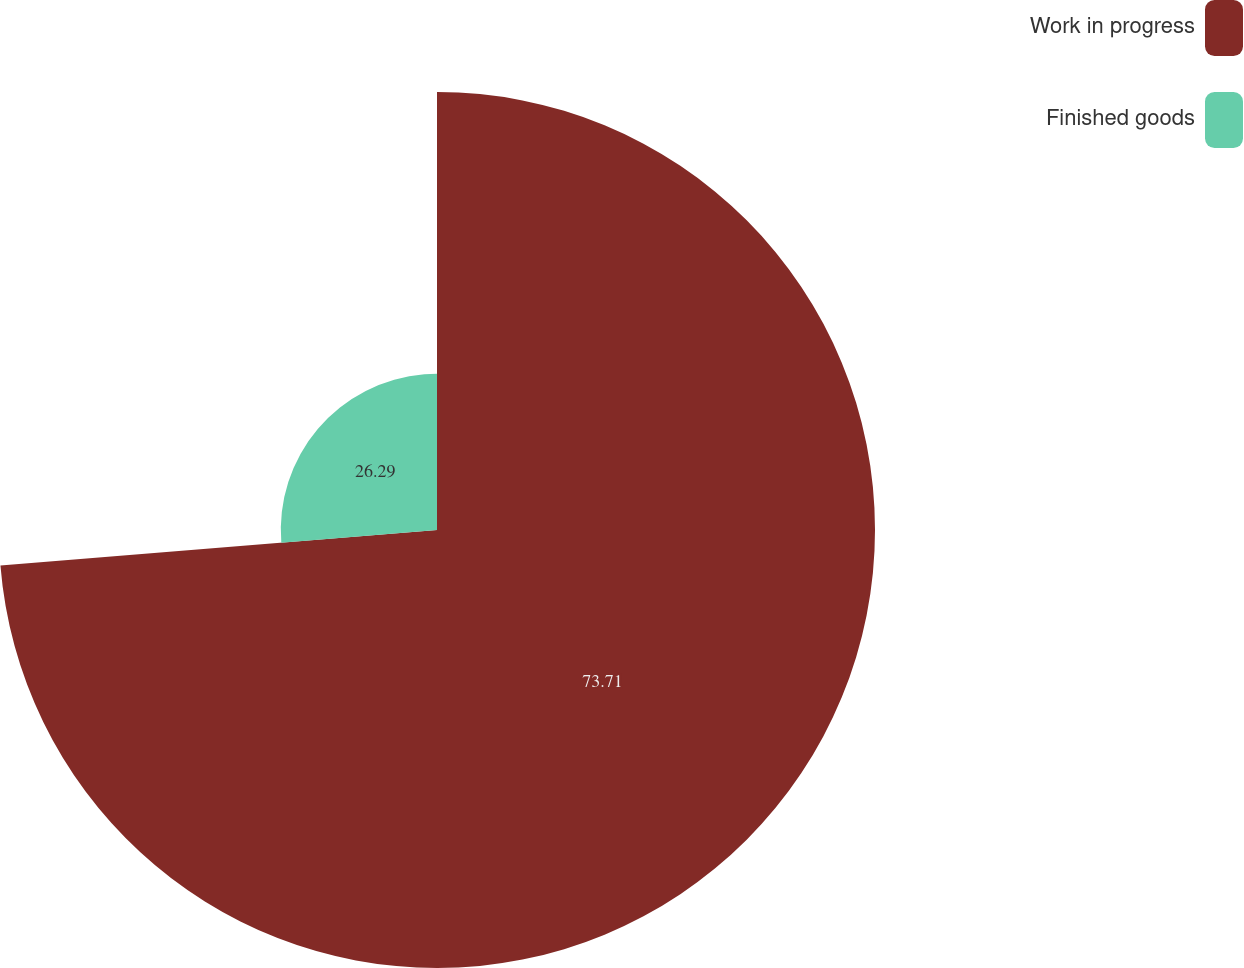Convert chart. <chart><loc_0><loc_0><loc_500><loc_500><pie_chart><fcel>Work in progress<fcel>Finished goods<nl><fcel>73.71%<fcel>26.29%<nl></chart> 